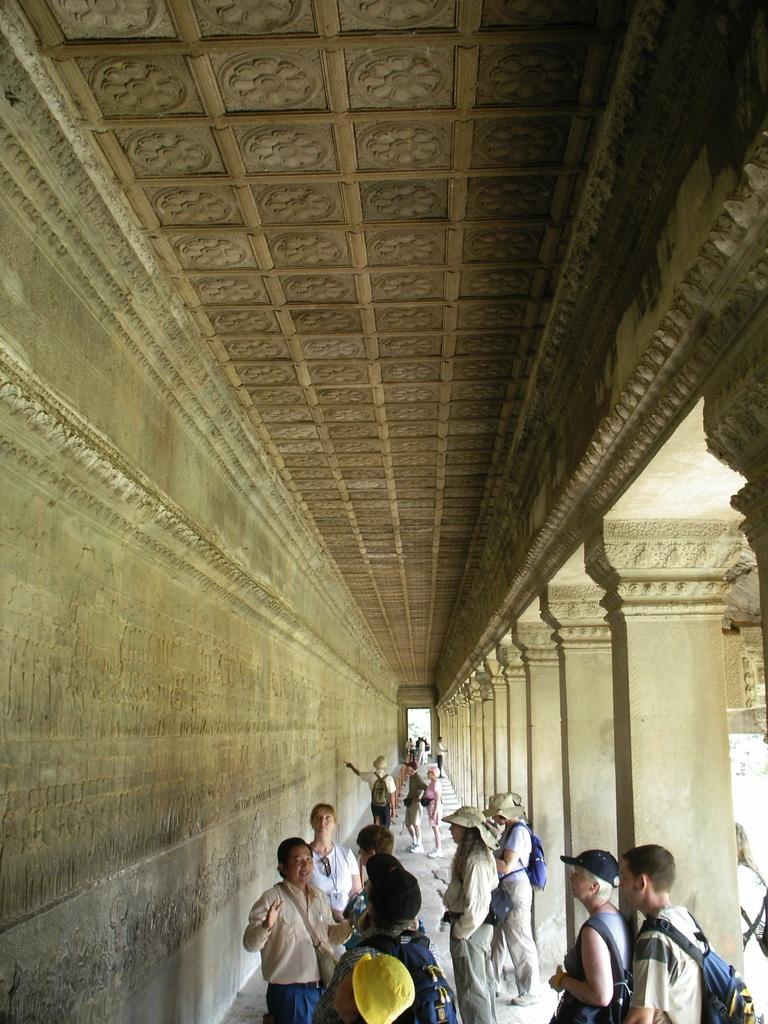How would you summarize this image in a sentence or two? In this picture I can see there is a group of people standing and they are having hats and bags. There is a sculpture on the wall at the left side and there are pillars on the right side. 